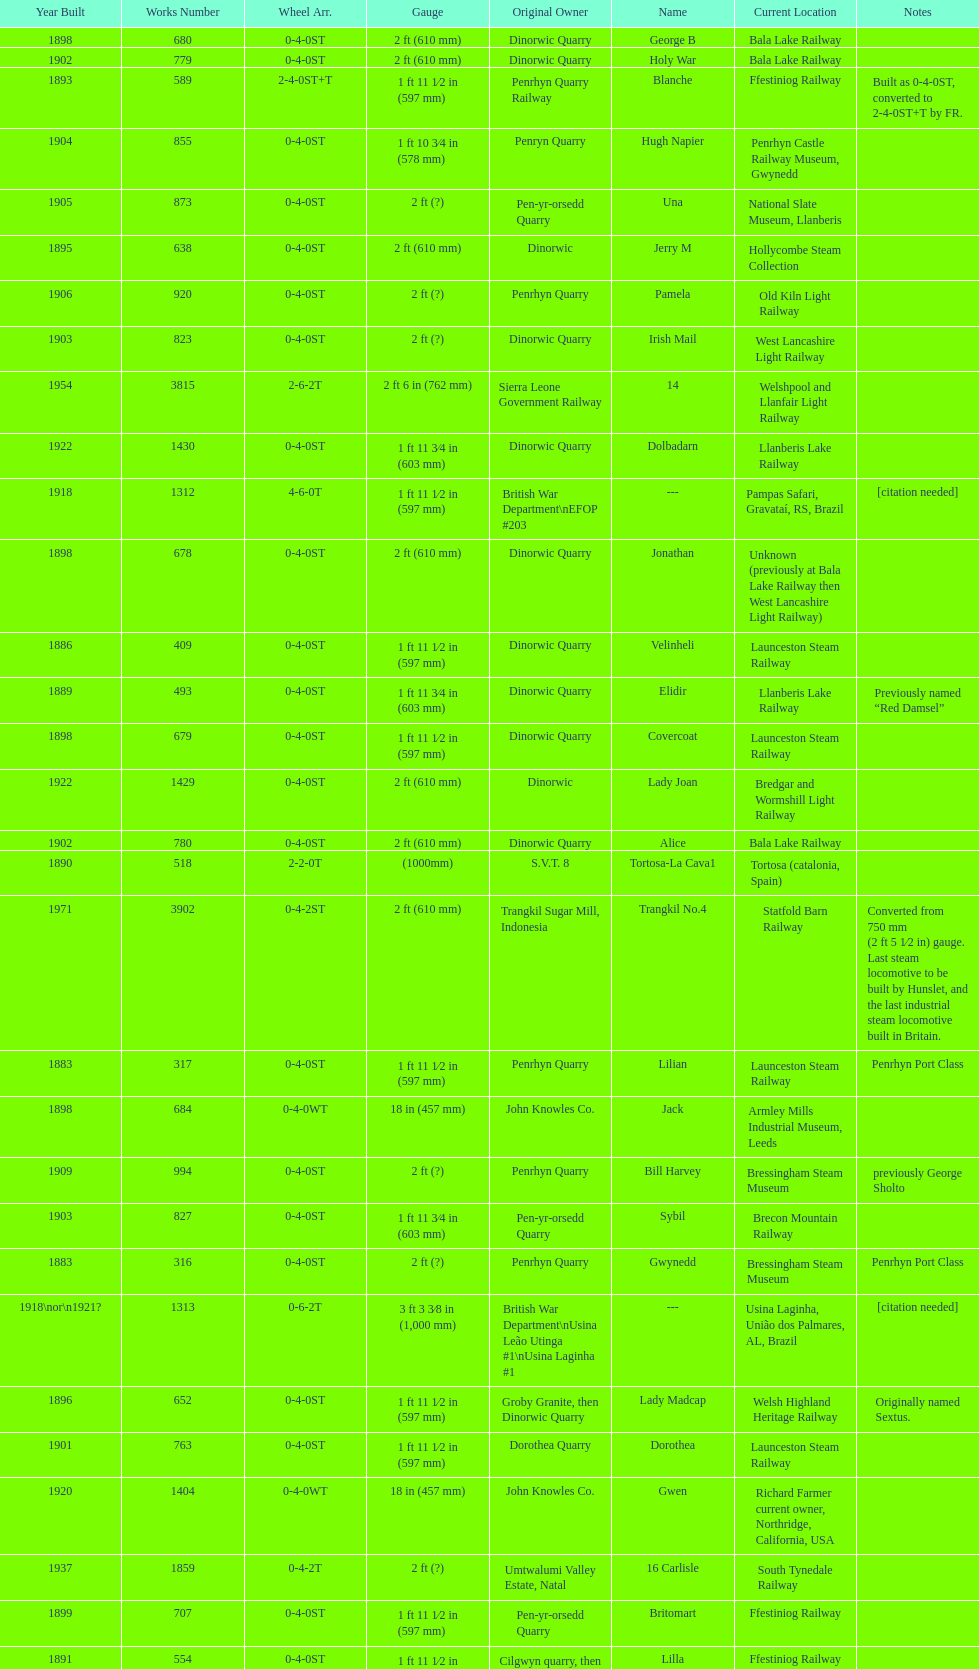After 1940, how many steam locomotives were built? 2. 